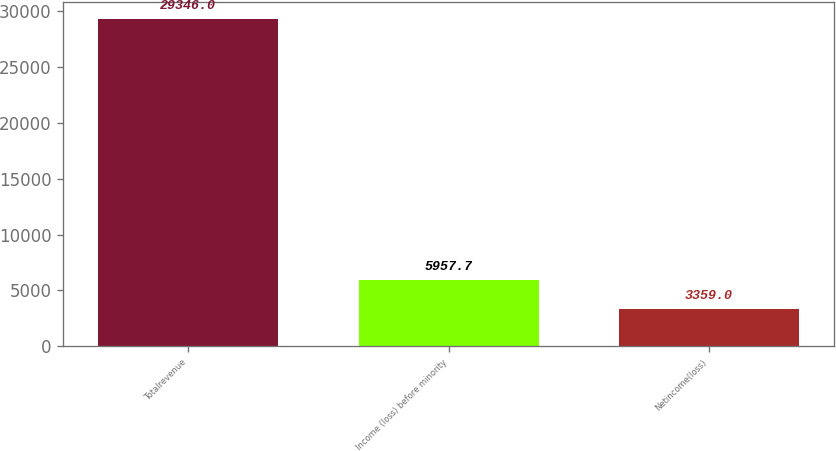Convert chart to OTSL. <chart><loc_0><loc_0><loc_500><loc_500><bar_chart><fcel>Totalrevenue<fcel>Income (loss) before minority<fcel>Netincome(loss)<nl><fcel>29346<fcel>5957.7<fcel>3359<nl></chart> 